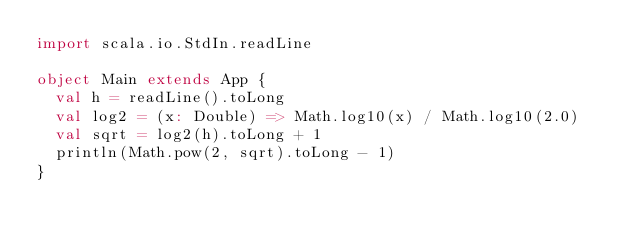Convert code to text. <code><loc_0><loc_0><loc_500><loc_500><_Scala_>import scala.io.StdIn.readLine

object Main extends App {
  val h = readLine().toLong
  val log2 = (x: Double) => Math.log10(x) / Math.log10(2.0)
  val sqrt = log2(h).toLong + 1
  println(Math.pow(2, sqrt).toLong - 1)
}</code> 